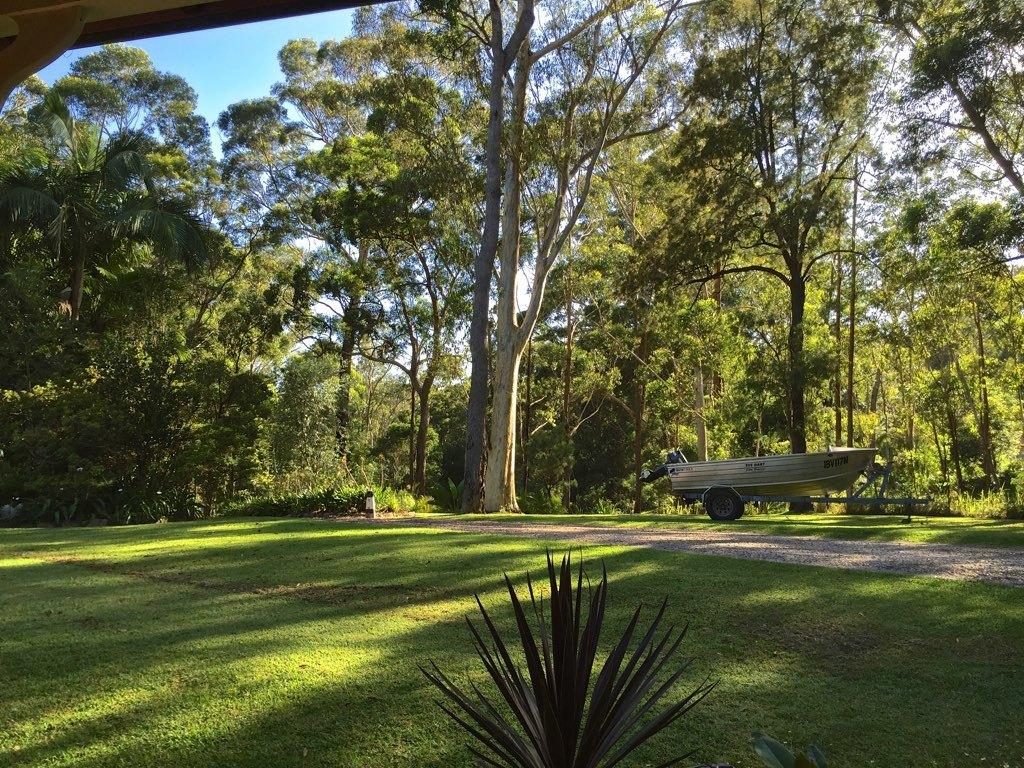What type of vegetation is present in the image? There are trees in the image. What is covering the ground in the image? There is grass on the ground in the image. What can be seen in the background of the image? The sky is visible in the background of the image. What type of steel object can be seen in the image? There is no steel object present in the image. What is the cup used for in the image? There is no cup present in the image. 